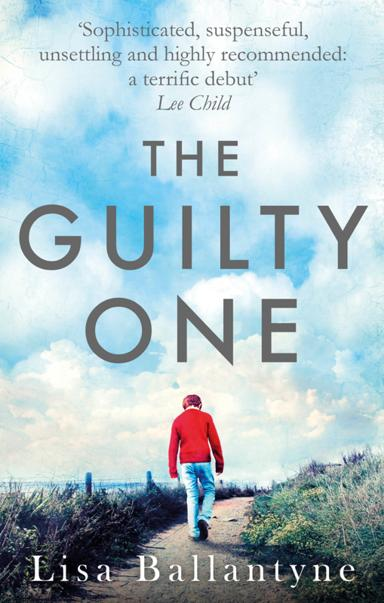Can you please explain what the imagery on the book cover might symbolize? The imagery on the cover, showing a person walking alone along a rural path under an expansive sky, likely symbolizes the journey of the main character grappling with complex emotions and a past that affects his present. It reflects themes of solitude, introspection, and the journey towards redemption or resolution. 